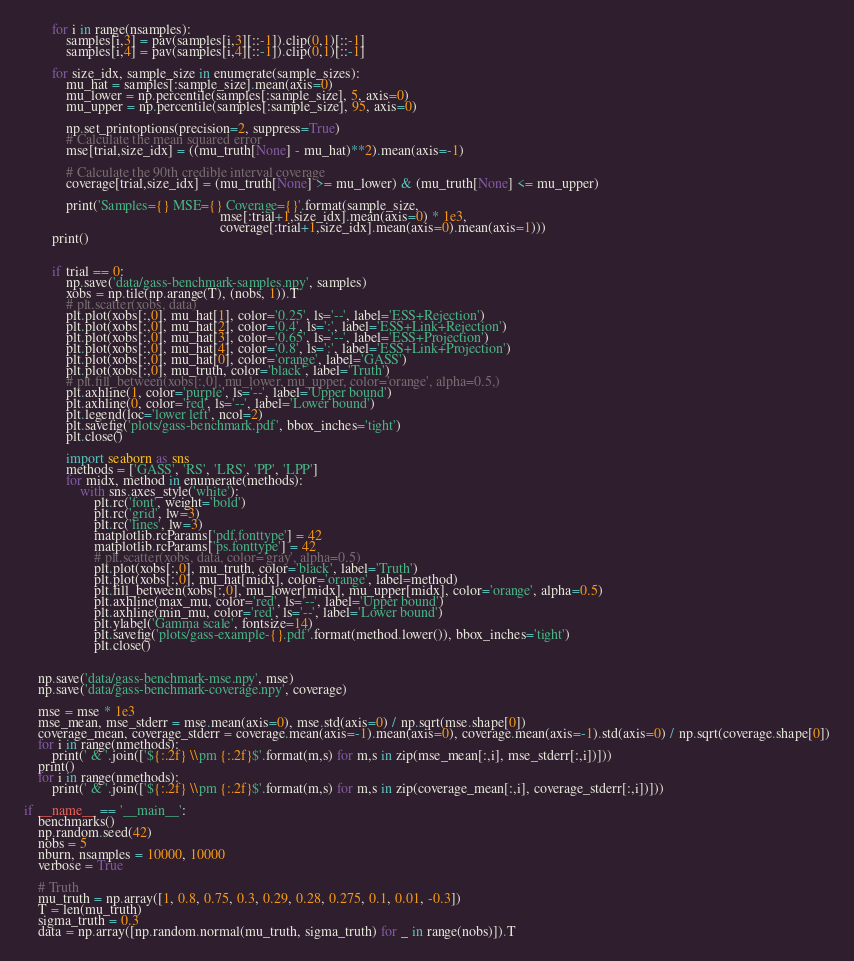Convert code to text. <code><loc_0><loc_0><loc_500><loc_500><_Python_>        for i in range(nsamples):
            samples[i,3] = pav(samples[i,3][::-1]).clip(0,1)[::-1]
            samples[i,4] = pav(samples[i,4][::-1]).clip(0,1)[::-1]

        for size_idx, sample_size in enumerate(sample_sizes):
            mu_hat = samples[:sample_size].mean(axis=0)
            mu_lower = np.percentile(samples[:sample_size], 5, axis=0)
            mu_upper = np.percentile(samples[:sample_size], 95, axis=0)

            np.set_printoptions(precision=2, suppress=True)
            # Calculate the mean squared error
            mse[trial,size_idx] = ((mu_truth[None] - mu_hat)**2).mean(axis=-1)

            # Calculate the 90th credible interval coverage
            coverage[trial,size_idx] = (mu_truth[None] >= mu_lower) & (mu_truth[None] <= mu_upper)
            
            print('Samples={} MSE={} Coverage={}'.format(sample_size,
                                                        mse[:trial+1,size_idx].mean(axis=0) * 1e3,
                                                        coverage[:trial+1,size_idx].mean(axis=0).mean(axis=1)))
        print()

            
        if trial == 0:
            np.save('data/gass-benchmark-samples.npy', samples)
            xobs = np.tile(np.arange(T), (nobs, 1)).T
            # plt.scatter(xobs, data)
            plt.plot(xobs[:,0], mu_hat[1], color='0.25', ls='--', label='ESS+Rejection')
            plt.plot(xobs[:,0], mu_hat[2], color='0.4', ls=':', label='ESS+Link+Rejection')
            plt.plot(xobs[:,0], mu_hat[3], color='0.65', ls='--', label='ESS+Projection')
            plt.plot(xobs[:,0], mu_hat[4], color='0.8', ls=':', label='ESS+Link+Projection')
            plt.plot(xobs[:,0], mu_hat[0], color='orange', label='GASS')
            plt.plot(xobs[:,0], mu_truth, color='black', label='Truth')
            # plt.fill_between(xobs[:,0], mu_lower, mu_upper, color='orange', alpha=0.5,)
            plt.axhline(1, color='purple', ls='--', label='Upper bound')
            plt.axhline(0, color='red', ls='--', label='Lower bound')
            plt.legend(loc='lower left', ncol=2)
            plt.savefig('plots/gass-benchmark.pdf', bbox_inches='tight')
            plt.close()

            import seaborn as sns
            methods = ['GASS', 'RS', 'LRS', 'PP', 'LPP']
            for midx, method in enumerate(methods):
                with sns.axes_style('white'):
                    plt.rc('font', weight='bold')
                    plt.rc('grid', lw=3)
                    plt.rc('lines', lw=3)
                    matplotlib.rcParams['pdf.fonttype'] = 42
                    matplotlib.rcParams['ps.fonttype'] = 42
                    # plt.scatter(xobs, data, color='gray', alpha=0.5)
                    plt.plot(xobs[:,0], mu_truth, color='black', label='Truth')
                    plt.plot(xobs[:,0], mu_hat[midx], color='orange', label=method)
                    plt.fill_between(xobs[:,0], mu_lower[midx], mu_upper[midx], color='orange', alpha=0.5)
                    plt.axhline(max_mu, color='red', ls='--', label='Upper bound')
                    plt.axhline(min_mu, color='red', ls='--', label='Lower bound')
                    plt.ylabel('Gamma scale', fontsize=14)
                    plt.savefig('plots/gass-example-{}.pdf'.format(method.lower()), bbox_inches='tight')
                    plt.close()
        
            
    np.save('data/gass-benchmark-mse.npy', mse)
    np.save('data/gass-benchmark-coverage.npy', coverage)

    mse = mse * 1e3
    mse_mean, mse_stderr = mse.mean(axis=0), mse.std(axis=0) / np.sqrt(mse.shape[0])
    coverage_mean, coverage_stderr = coverage.mean(axis=-1).mean(axis=0), coverage.mean(axis=-1).std(axis=0) / np.sqrt(coverage.shape[0])
    for i in range(nmethods):
        print(' & '.join(['${:.2f} \\pm {:.2f}$'.format(m,s) for m,s in zip(mse_mean[:,i], mse_stderr[:,i])]))
    print()
    for i in range(nmethods):
        print(' & '.join(['${:.2f} \\pm {:.2f}$'.format(m,s) for m,s in zip(coverage_mean[:,i], coverage_stderr[:,i])]))

if __name__ == '__main__':
    benchmarks()
    np.random.seed(42)
    nobs = 5
    nburn, nsamples = 10000, 10000
    verbose = True

    # Truth
    mu_truth = np.array([1, 0.8, 0.75, 0.3, 0.29, 0.28, 0.275, 0.1, 0.01, -0.3])
    T = len(mu_truth)
    sigma_truth = 0.3
    data = np.array([np.random.normal(mu_truth, sigma_truth) for _ in range(nobs)]).T
</code> 